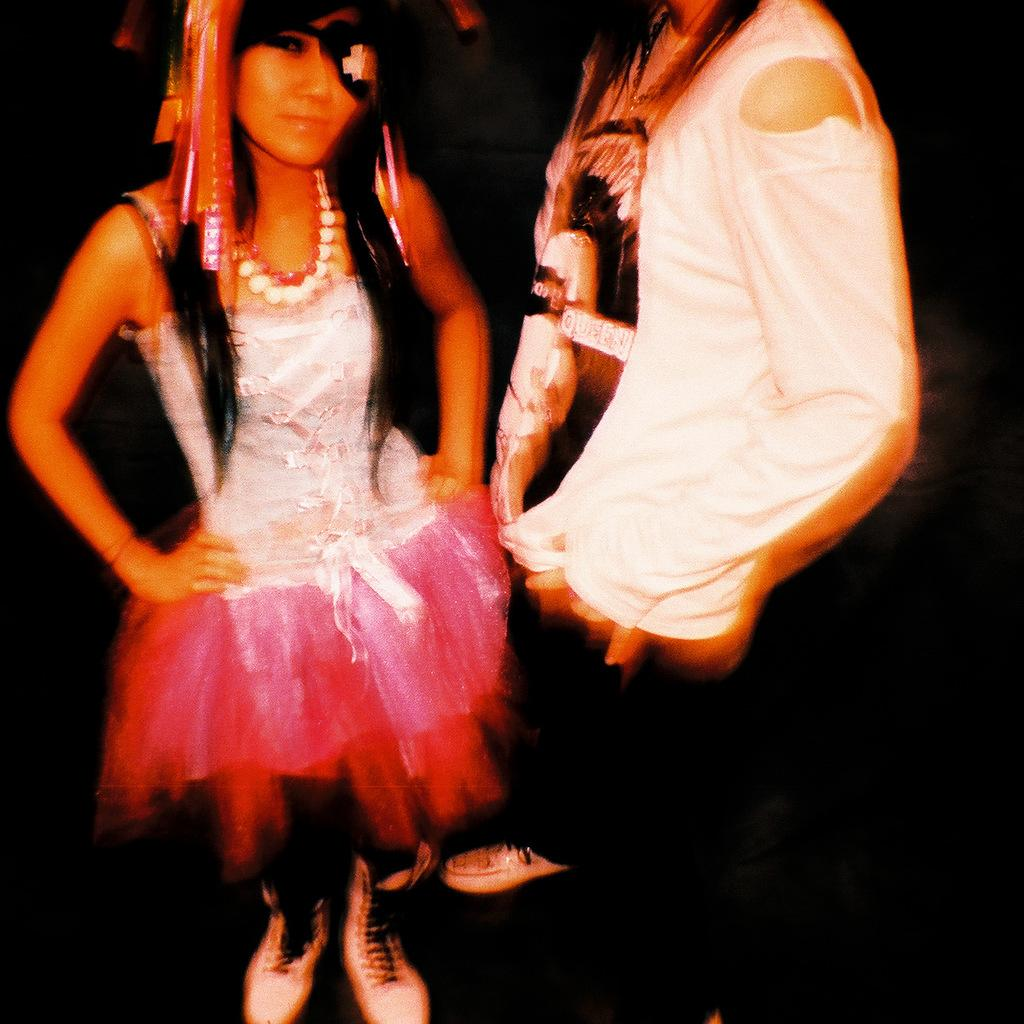What is the main subject of the image? There is a woman in the image. Can you describe the woman's attire? The woman is wearing a white and pink dress. What is the woman doing in the image? The woman is standing. Can you describe the person in the image? There is a person in the image, and they are wearing a white t-shirt. What is the person doing in the image? The person is standing. What is the color of the background in the image? The background of the image is black. How many lizards are crawling on the beam in the image? There is no beam or lizards present in the image. What type of company is represented by the woman in the image? The image does not provide any information about a company or the woman's affiliation with one. 